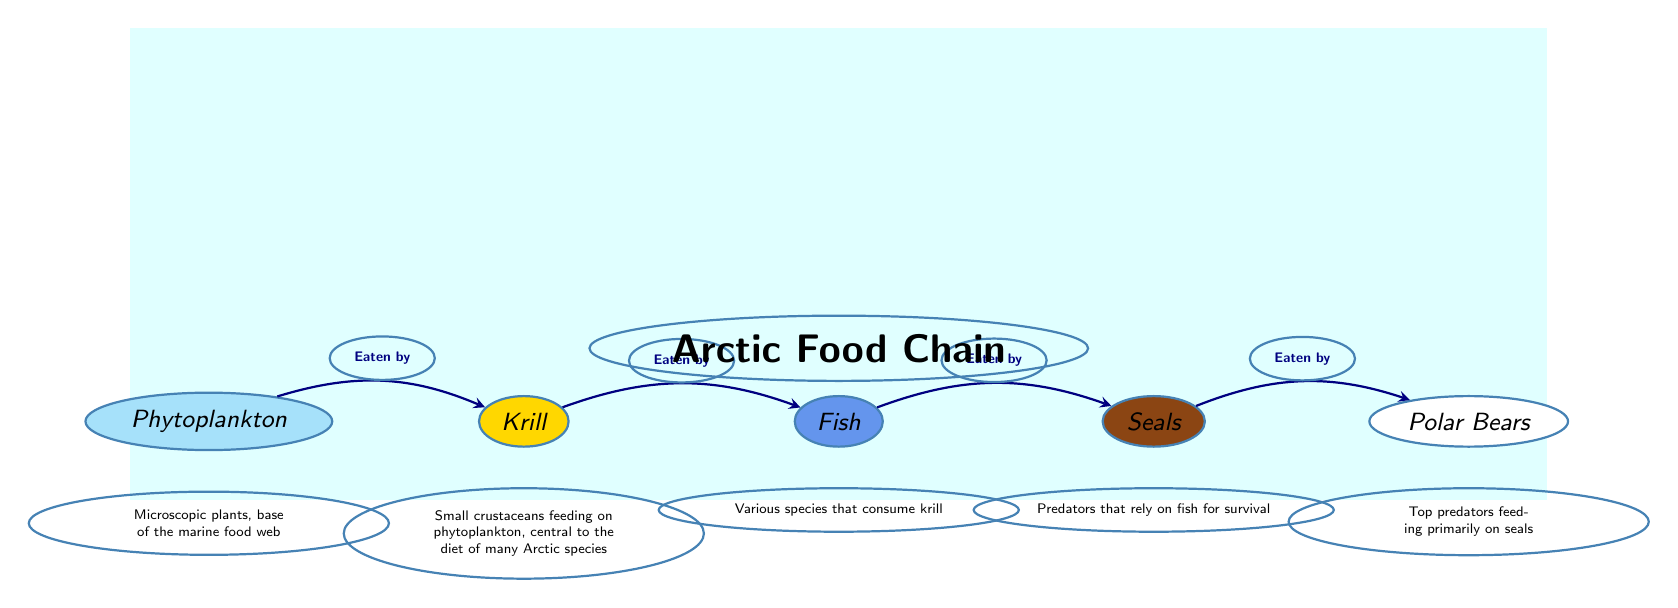What is the base of the marine food web? The diagram identifies phytoplankton as the base of the marine food web, indicating it provides foundational energy and nutrition for higher trophic levels.
Answer: Phytoplankton How many nodes are in the Arctic food chain? The diagram visually presents five distinct nodes, each representing a different species in the Arctic food chain.
Answer: Five Which species is eaten by seals? According to the diagram, the arrows indicate that seals prey on fish, establishing a direct predator-prey relationship.
Answer: Fish What is the role of krill in the food chain? The diagram labels krill as small crustaceans that feed on phytoplankton and serve as a central food source for many Arctic species, highlighting their key ecological role.
Answer: Central to the diet of many Arctic species Which species is at the top of the food chain? The last node in the diagram, corresponding to the final arrow, indicates polar bears as the apex predators within this Arctic food chain.
Answer: Polar Bears What do seals primarily rely on for survival? The diagram specifies that seals primarily depend on fish as their main food source, establishing their role as predators in the ecosystem.
Answer: Fish How many direct predator-prey relationships are shown in the diagram? The arrows between the species indicate four direct predator-prey relationships from phytoplankton to polar bears, showing the interconnectedness of the species.
Answer: Four What do polar bears primarily feed on? Based on the information provided in the diagram, polar bears specifically feed on seals, indicating their position in the food chain as apex predators.
Answer: Seals What type of species are krill? The diagram describes krill as small crustaceans that are primarily herbivorous, feeding on phytoplankton, thus categorizing them as primary consumers.
Answer: Crustaceans 